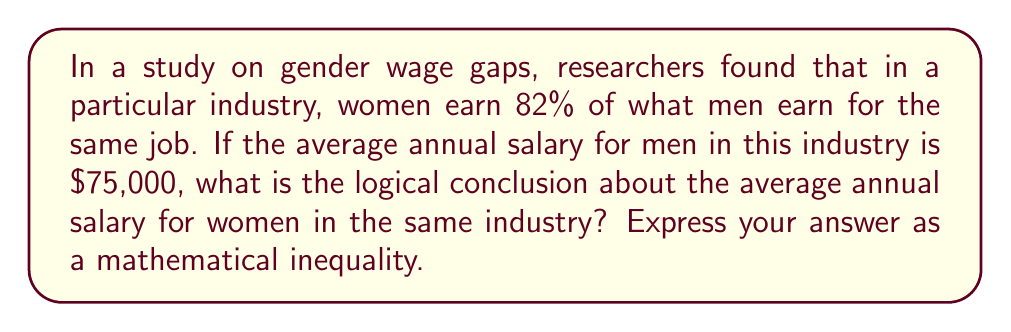Show me your answer to this math problem. To solve this problem, we need to follow these logical steps:

1. Let's define variables:
   $M$ = average annual salary for men
   $W$ = average annual salary for women

2. We know that women earn 82% of what men earn. This can be expressed as:
   $W = 0.82 \times M$

3. We're given that the average annual salary for men is $75,000:
   $M = 75,000$

4. Now, let's substitute this value into our equation:
   $W = 0.82 \times 75,000$

5. Simplify:
   $W = 61,500$

6. To express this as an inequality, we compare W to M:
   $W < M$

7. We can also express this more specifically:
   $61,500 < 75,000$

Therefore, the logical conclusion is that the average annual salary for women in this industry is less than $75,000, and specifically, less than or equal to $61,500.
Answer: $W \leq 61,500 < 75,000 = M$ 